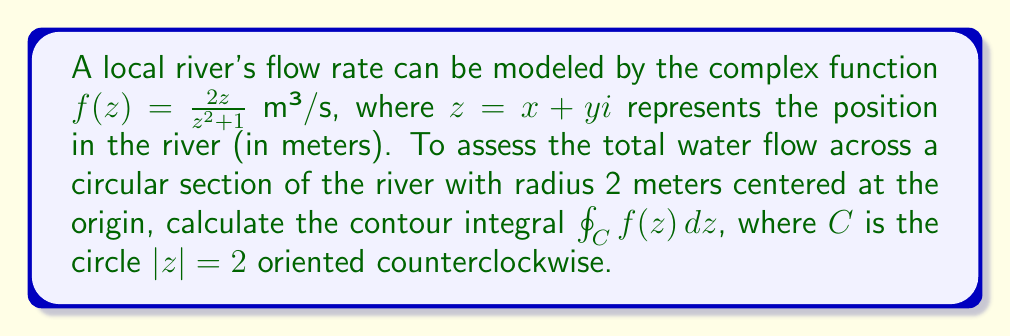Could you help me with this problem? To solve this problem, we'll use the Residue Theorem from complex analysis. The steps are as follows:

1) First, we need to identify the singularities of $f(z)$ inside the contour $C$. The function $f(z) = \frac{2z}{z^2 + 1}$ has singularities at $z = \pm i$.

2) The contour $C$ is $|z| = 2$, which encloses only the singularity at $z = i$.

3) We need to calculate the residue of $f(z)$ at $z = i$. We can do this using the formula for simple poles:

   $$\text{Res}(f, i) = \lim_{z \to i} (z-i)f(z) = \lim_{z \to i} \frac{2z(z-i)}{z^2 + 1}$$

4) Substituting $z = i + h$ and taking the limit as $h \to 0$:

   $$\lim_{h \to 0} \frac{2(i+h)(h)}{(i+h)^2 + 1} = \lim_{h \to 0} \frac{2ih + 2h^2}{-2ih + h^2 + 2} = \frac{2i}{2} = i$$

5) Now we can apply the Residue Theorem:

   $$\oint_C f(z) dz = 2\pi i \sum \text{Res}(f, a_k)$$

   where $a_k$ are the singularities inside $C$.

6) In this case, we have only one singularity inside $C$, so:

   $$\oint_C f(z) dz = 2\pi i \cdot \text{Res}(f, i) = 2\pi i \cdot i = -2\pi$$

7) The negative sign indicates that the flow is in the opposite direction of the counterclockwise orientation of $C$.

Therefore, the total water flow across this circular section of the river is $2\pi$ m³/s in the clockwise direction.
Answer: $-2\pi$ m³/s 